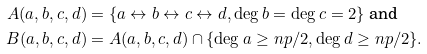<formula> <loc_0><loc_0><loc_500><loc_500>A ( a , b , c , d ) & = \{ a \leftrightarrow b \leftrightarrow c \leftrightarrow d , \deg b = \deg c = 2 \} \text { and } \\ B ( a , b , c , d ) & = A ( a , b , c , d ) \cap \{ \deg a \geq n p / 2 , \deg d \geq n p / 2 \} .</formula> 